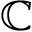Convert formula to latex. <formula><loc_0><loc_0><loc_500><loc_500>\mathbb { C }</formula> 